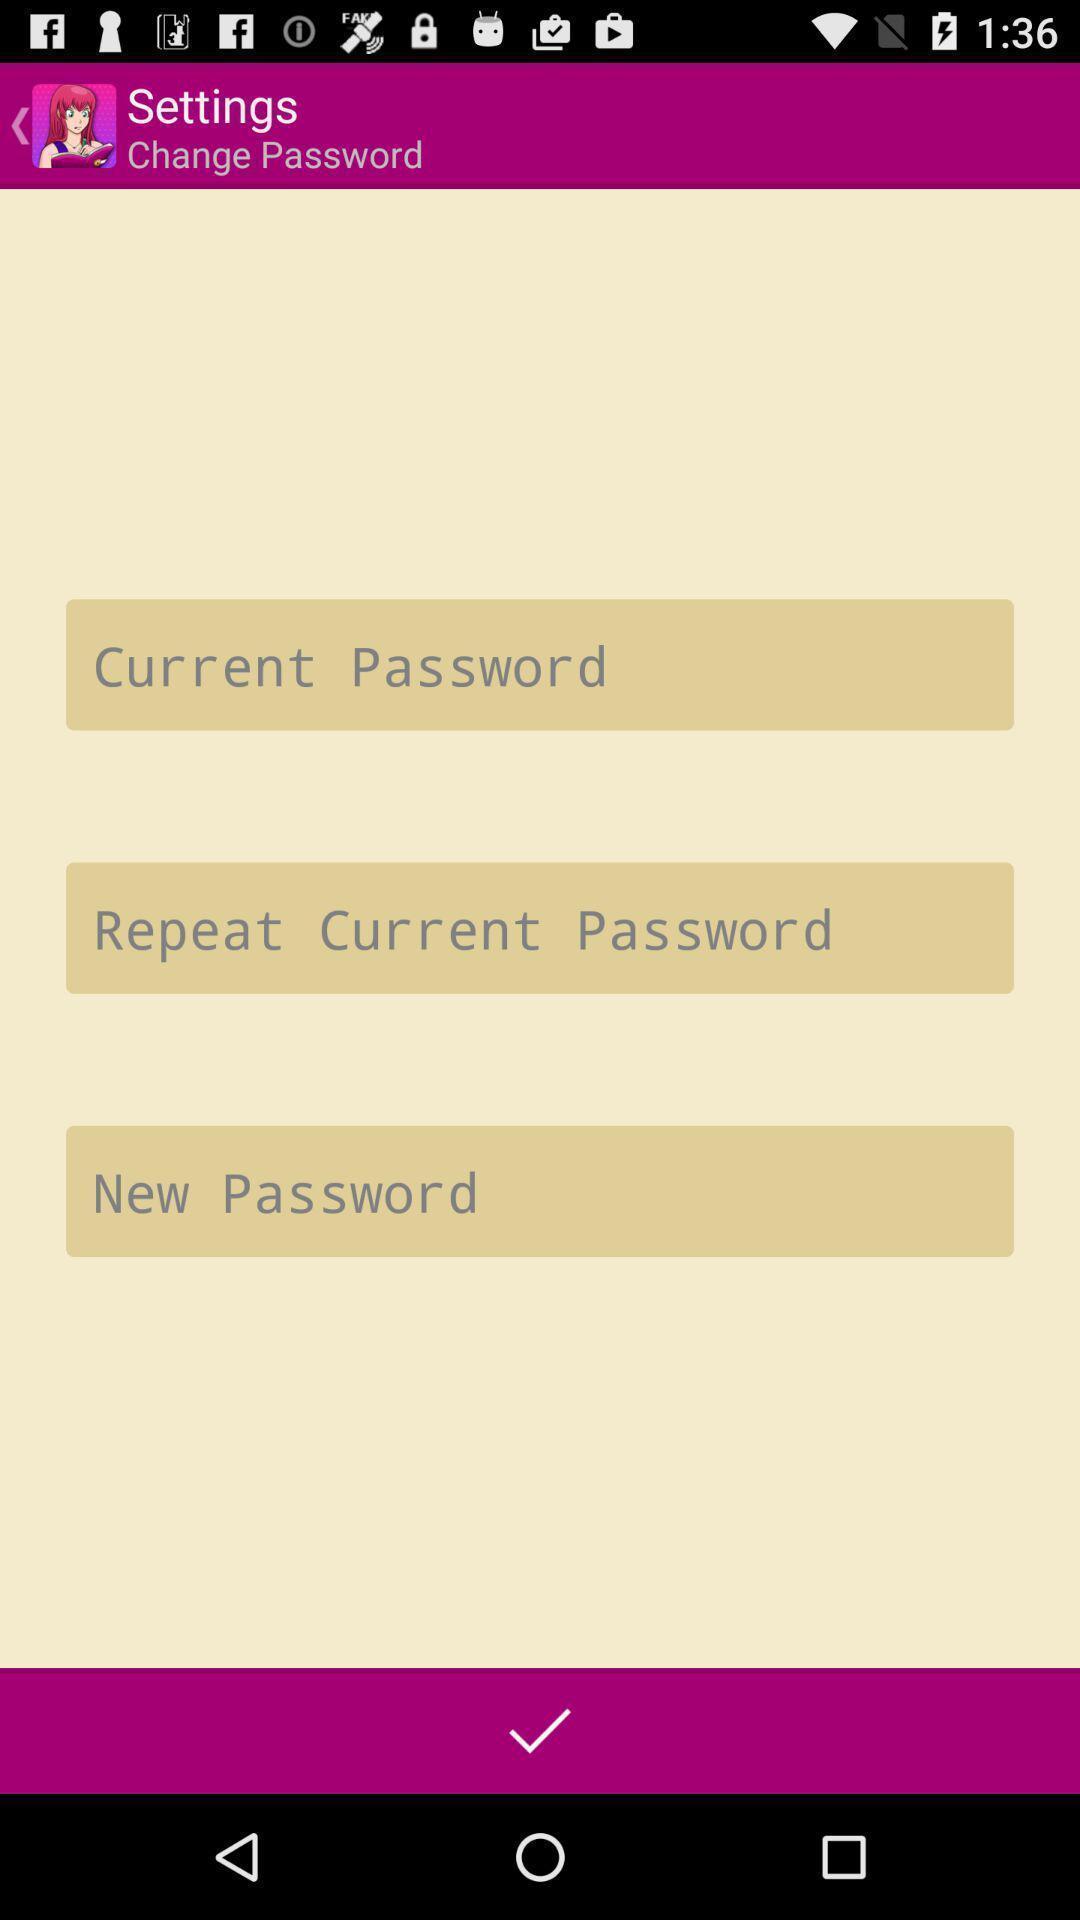Explain the elements present in this screenshot. Screen displays about changing password. 